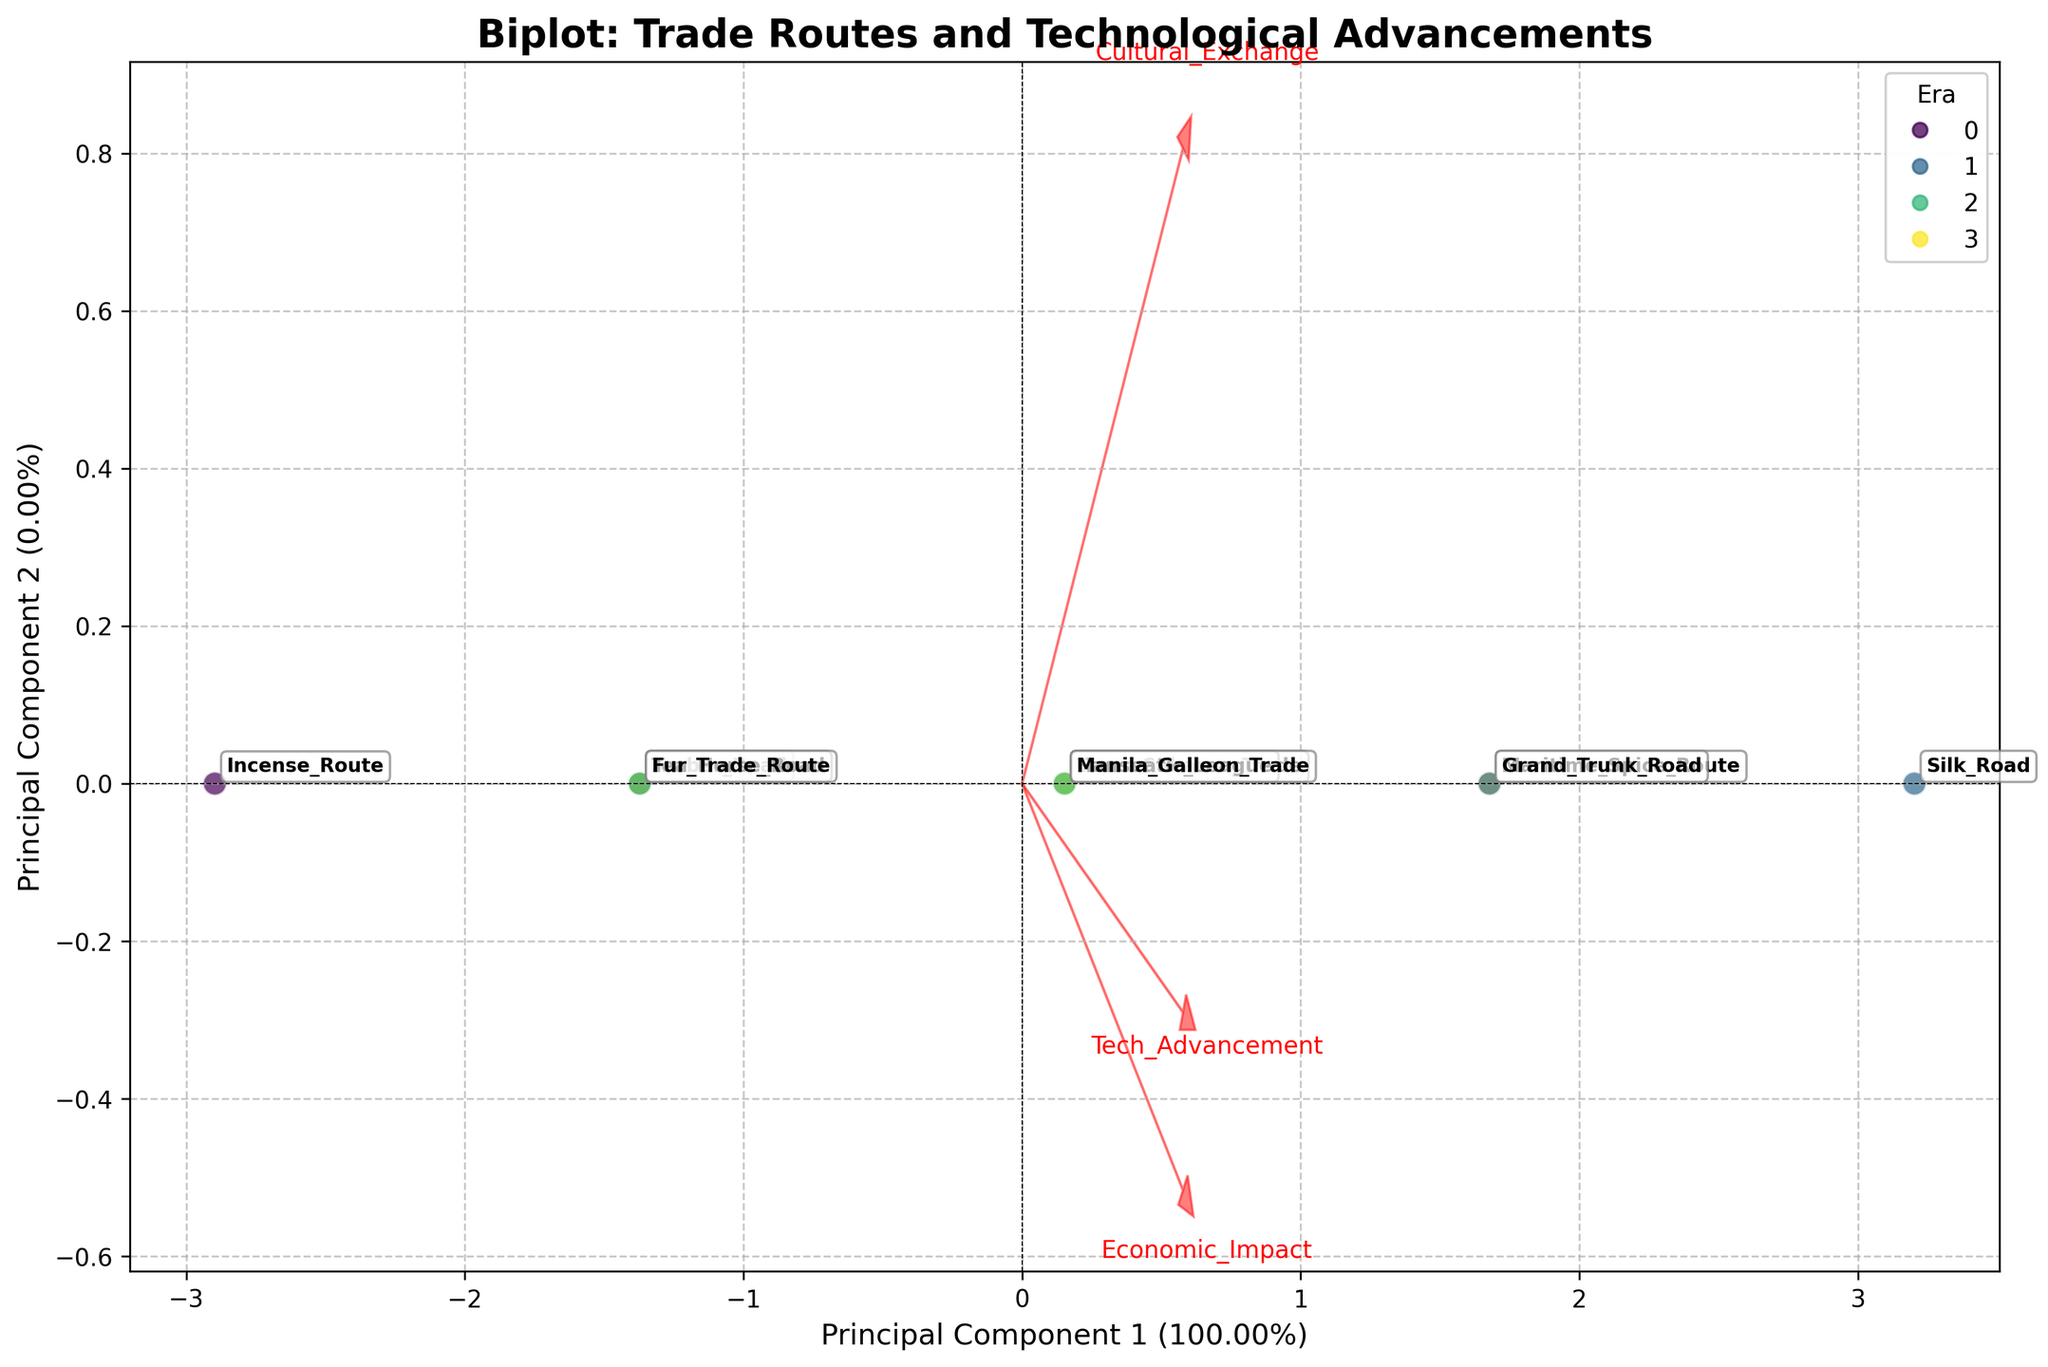What is the title of the figure? The title is usually displayed at the top of the figure and it summarizes what the visualization is about.
Answer: Biplot: Trade Routes and Technological Advancements How many trade routes are represented in the figure? Each data point in the biplot corresponds to a trade route, which can be counted to get the total number.
Answer: 10 Which era has the most trade routes represented in the figure? By examining the colors or labels associated with each era, count the data points for each era to determine which one has the most.
Answer: Medieval Which trade route is associated with the highest "Tech_Advancement"? Look at the position of the data points along the first principal component axis; the one furthest in the direction where "Tech_Advancement" vector points indicates the highest value.
Answer: Silk Road Between the "Silk Road" and "Grand Trunk Road," which one has a higher "Economic_Impact"? Compare their positions relative to the "Economic_Impact" vector; the one closer to or more aligned with the vector has a higher value.
Answer: Silk Road Are the trade routes in the 'Medieval' era generally more aligned with economic impact or cultural exchange based on the biplot vectors? Observe the clustering of Medieval era trade routes and their proximity/alignment with the "Economic_Impact" and "Cultural_Exchange" vectors. Assess which vector they predominantly align with.
Answer: Economic Impact Which axes are used to represent the principal components and what are their explained variance ratios? Identify the labels on the x and y axes of the biplot which usually state the principal components and their corresponding explained variance ratios.
Answer: Principal Component 1 (W%) and Principal Component 2 (X%) What is the primary era for the "Trans-Saharan Trade"? Identify the label or color coding associated with the "Trans-Saharan Trade" data point to determine its era.
Answer: Medieval Is there a trade route from the 'Ancient' era close to the origin of the biplot? Examine the positions of the data points labeled as 'Ancient' and check if any of them are near the coordinates (0,0).
Answer: Yes (Incense Route) 